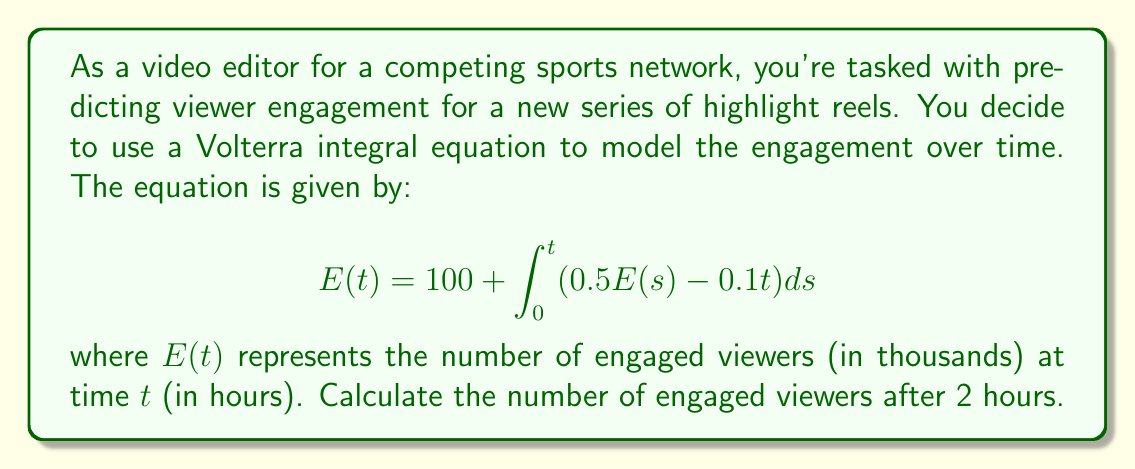Solve this math problem. To solve this Volterra integral equation, we'll follow these steps:

1) First, we differentiate both sides of the equation with respect to $t$:

   $$\frac{dE}{dt} = 0 + (0.5E(t) - 0.1t)$$

2) This gives us a first-order linear differential equation:

   $$\frac{dE}{dt} - 0.5E = -0.1t$$

3) To solve this, we use an integrating factor. The integrating factor is $e^{-0.5t}$:

   $$e^{-0.5t}\frac{dE}{dt} - 0.5e^{-0.5t}E = -0.1te^{-0.5t}$$

4) The left side is now the derivative of $e^{-0.5t}E$:

   $$\frac{d}{dt}(e^{-0.5t}E) = -0.1te^{-0.5t}$$

5) Integrating both sides:

   $$e^{-0.5t}E = 0.2te^{-0.5t} - 0.4e^{-0.5t} + C$$

6) Solving for $E$:

   $$E = 0.2t - 0.4 + Ce^{0.5t}$$

7) Using the initial condition $E(0) = 100$:

   $$100 = -0.4 + C$$
   $$C = 100.4$$

8) Therefore, the solution is:

   $$E(t) = 0.2t - 0.4 + 100.4e^{0.5t}$$

9) To find $E(2)$, we substitute $t = 2$:

   $$E(2) = 0.2(2) - 0.4 + 100.4e^{0.5(2)}$$
   $$E(2) = 0.4 - 0.4 + 100.4e^1$$
   $$E(2) = 100.4e \approx 272.97$$
Answer: 273 thousand viewers (rounded to nearest thousand) 